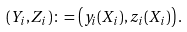Convert formula to latex. <formula><loc_0><loc_0><loc_500><loc_500>( Y _ { i } , Z _ { i } ) \colon = \left ( y _ { i } ( X _ { i } ) , z _ { i } ( X _ { i } ) \right ) .</formula> 